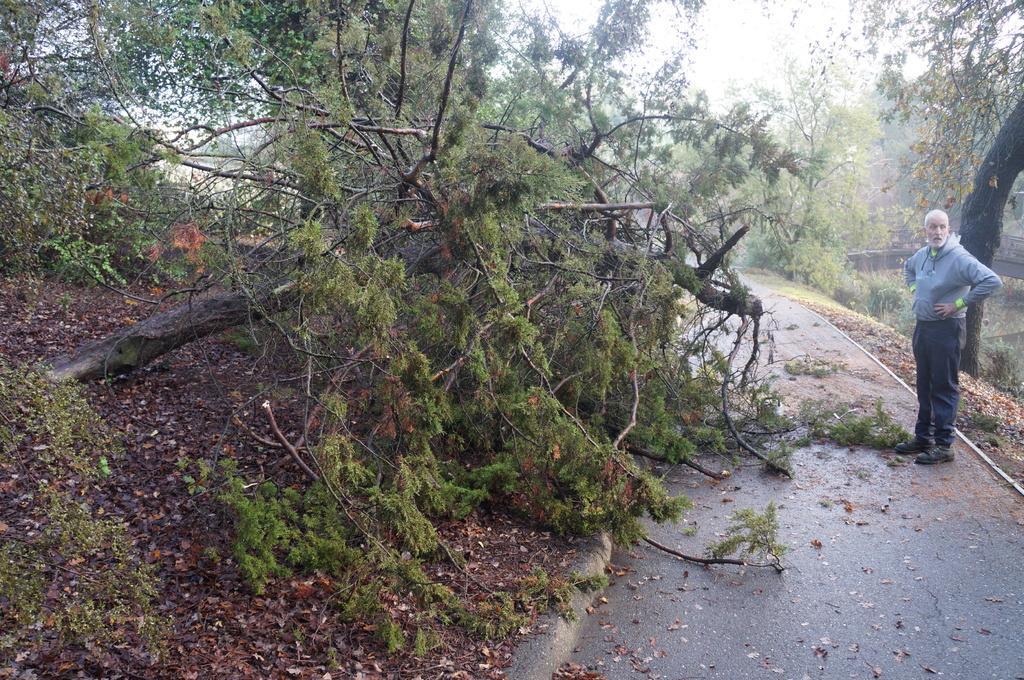Describe this image in one or two sentences. There are trees. A person is standing wearing t shirt, trousers and shoes. 